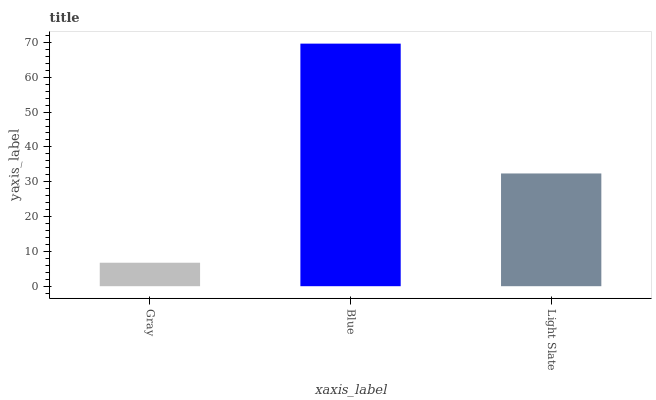Is Gray the minimum?
Answer yes or no. Yes. Is Blue the maximum?
Answer yes or no. Yes. Is Light Slate the minimum?
Answer yes or no. No. Is Light Slate the maximum?
Answer yes or no. No. Is Blue greater than Light Slate?
Answer yes or no. Yes. Is Light Slate less than Blue?
Answer yes or no. Yes. Is Light Slate greater than Blue?
Answer yes or no. No. Is Blue less than Light Slate?
Answer yes or no. No. Is Light Slate the high median?
Answer yes or no. Yes. Is Light Slate the low median?
Answer yes or no. Yes. Is Gray the high median?
Answer yes or no. No. Is Blue the low median?
Answer yes or no. No. 